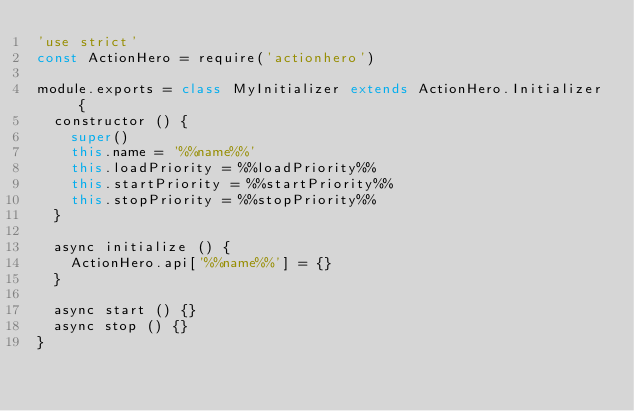Convert code to text. <code><loc_0><loc_0><loc_500><loc_500><_JavaScript_>'use strict'
const ActionHero = require('actionhero')

module.exports = class MyInitializer extends ActionHero.Initializer {
  constructor () {
    super()
    this.name = '%%name%%'
    this.loadPriority = %%loadPriority%%
    this.startPriority = %%startPriority%%
    this.stopPriority = %%stopPriority%%
  }

  async initialize () {
    ActionHero.api['%%name%%'] = {}
  }

  async start () {}
  async stop () {}
}
</code> 